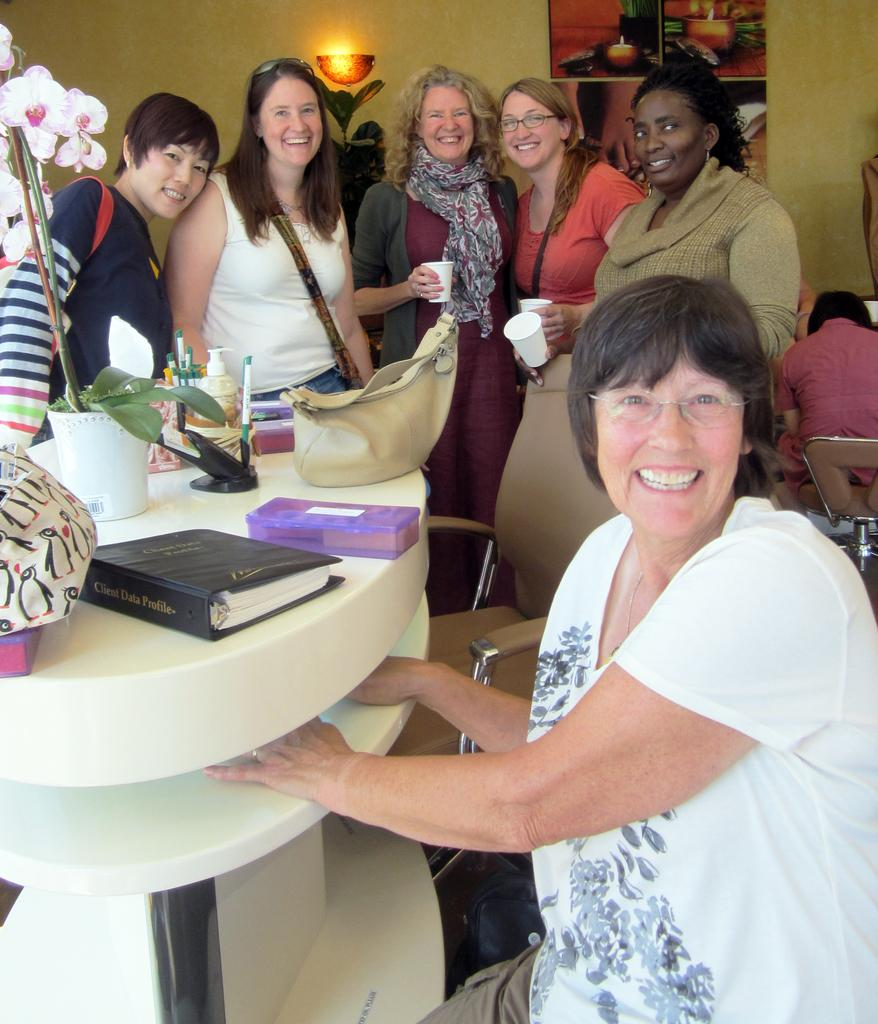Provide a one-sentence caption for the provided image. A group of women smile standing around a table with a Client Data Profile sitting on the table. 